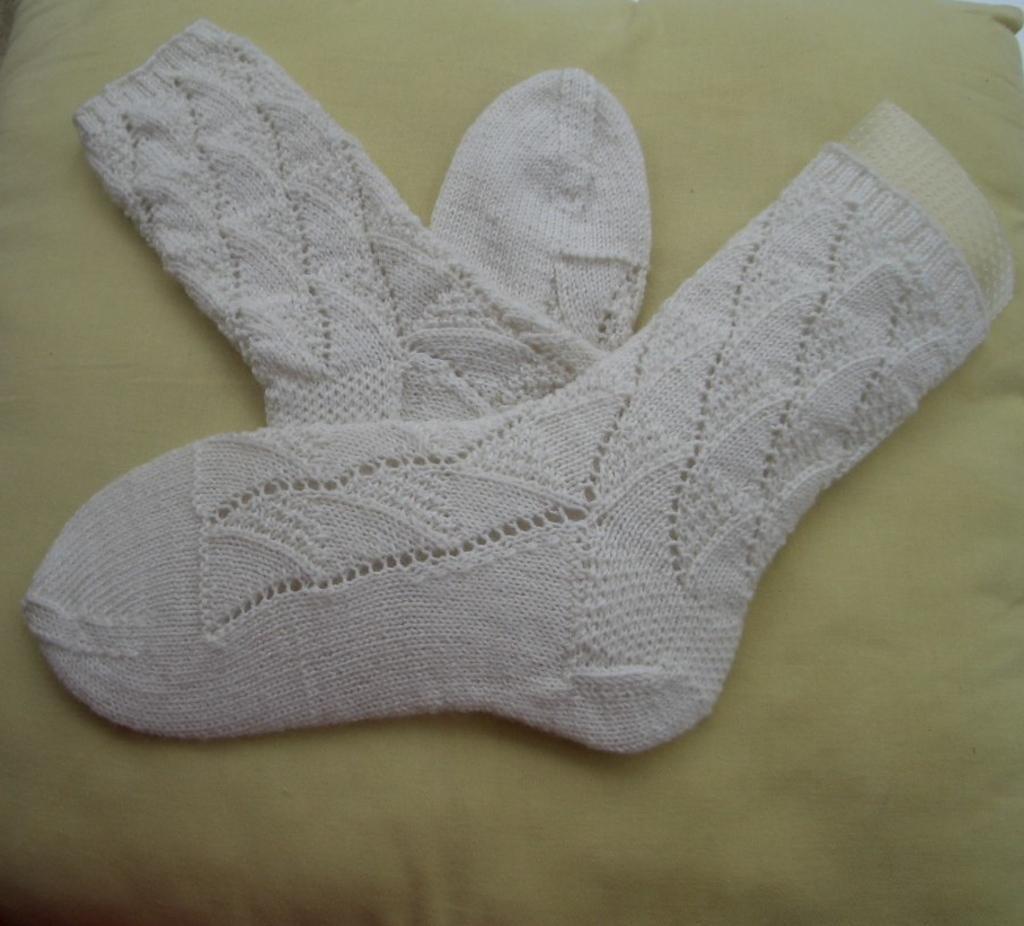Please provide a concise description of this image. In this image there are white color sockś on the pillow. 